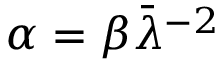<formula> <loc_0><loc_0><loc_500><loc_500>\alpha = \beta \bar { \lambda } ^ { - 2 }</formula> 